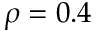Convert formula to latex. <formula><loc_0><loc_0><loc_500><loc_500>\rho = 0 . 4</formula> 